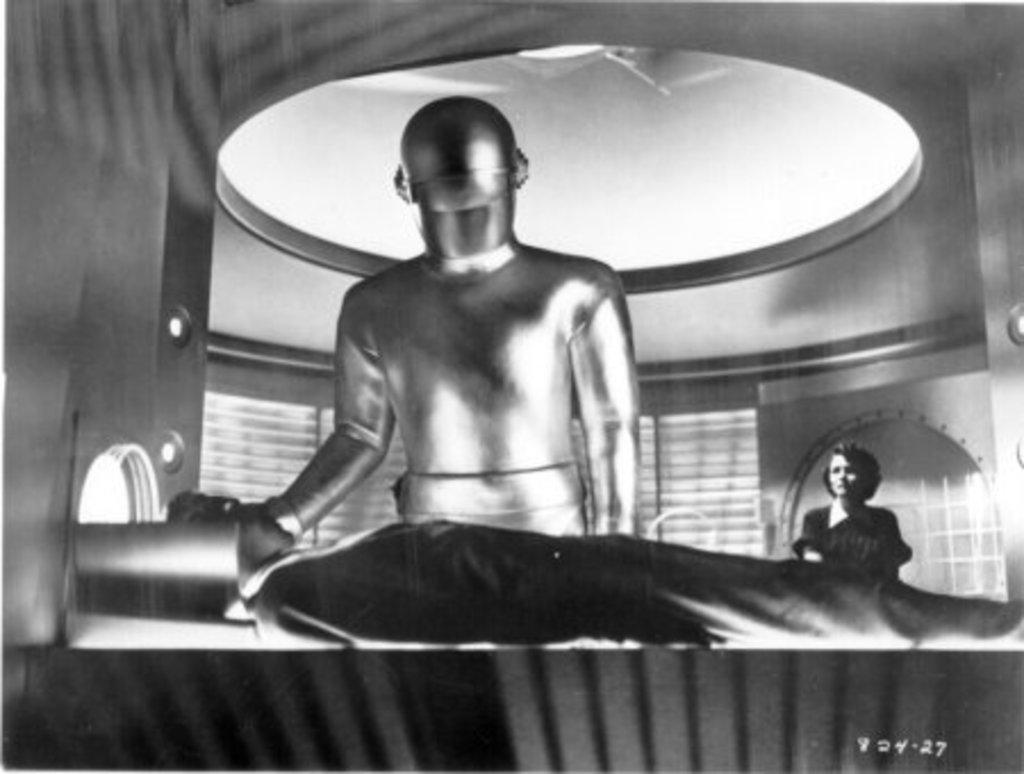Can you describe this image briefly? In this black and white picture there is a person lying on the floor. Beside him there is another person standing. To the right there is a woman standing. In the background there is a wall. In the bottom right there are numbers on the image. 